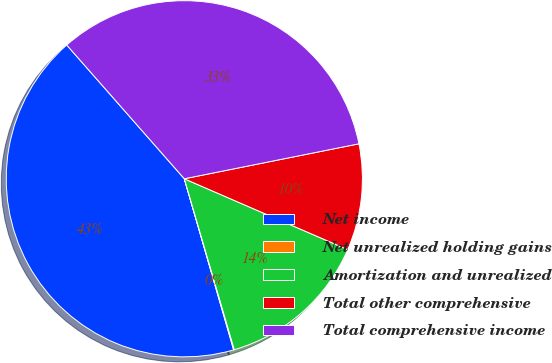Convert chart to OTSL. <chart><loc_0><loc_0><loc_500><loc_500><pie_chart><fcel>Net income<fcel>Net unrealized holding gains<fcel>Amortization and unrealized<fcel>Total other comprehensive<fcel>Total comprehensive income<nl><fcel>42.99%<fcel>0.06%<fcel>13.96%<fcel>9.66%<fcel>33.33%<nl></chart> 